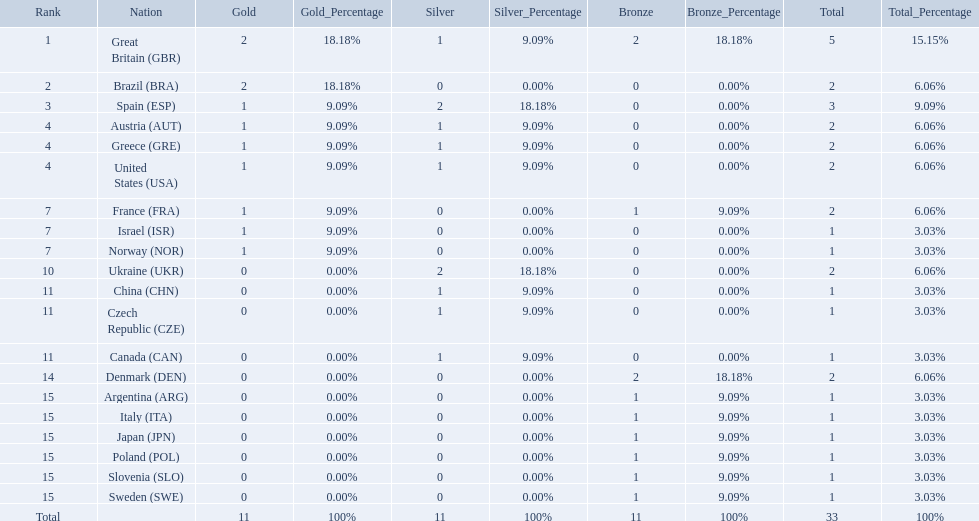How many medals did each country receive? 5, 2, 3, 2, 2, 2, 2, 1, 1, 2, 1, 1, 1, 2, 1, 1, 1, 1, 1, 1. Which country received 3 medals? Spain (ESP). How many medals did spain gain 3. Only country that got more medals? Spain (ESP). 